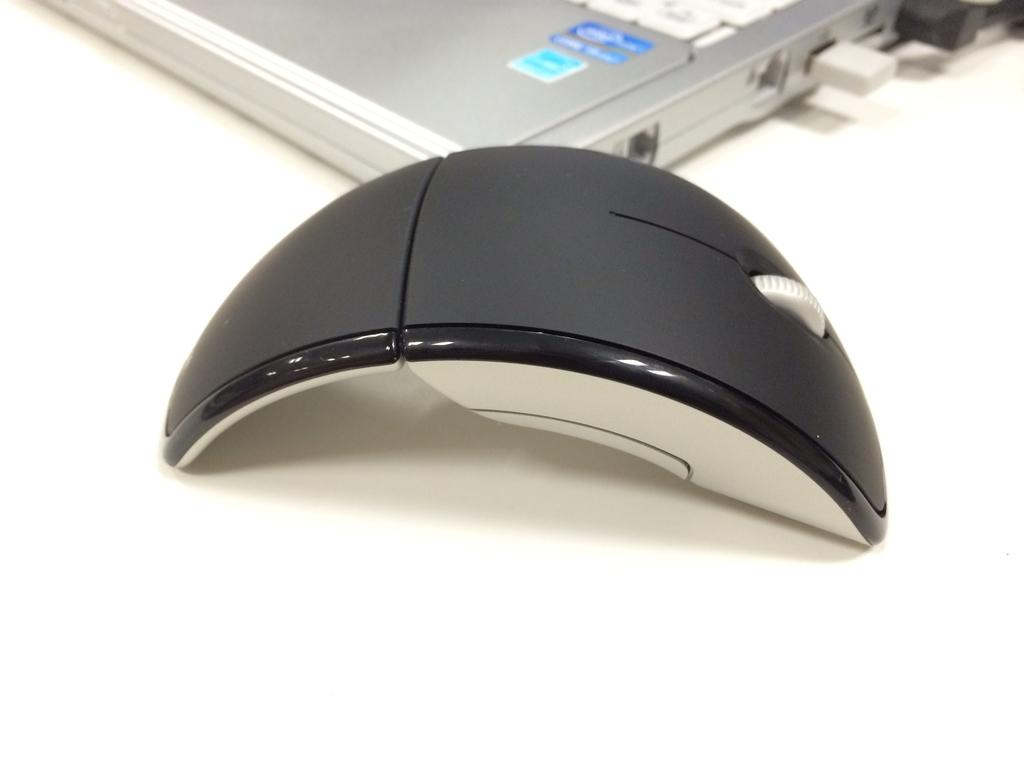What type of animal is in the image? There is a mouse in the image. What other object is present in the image? There is a device in the image. What is the color of the surface on which the mouse and device are placed? The mouse and device are placed on a white surface. What type of crayon is the mouse using to color the device in the image? There is no crayon present in the image, nor is the mouse using any crayon to color the device. 